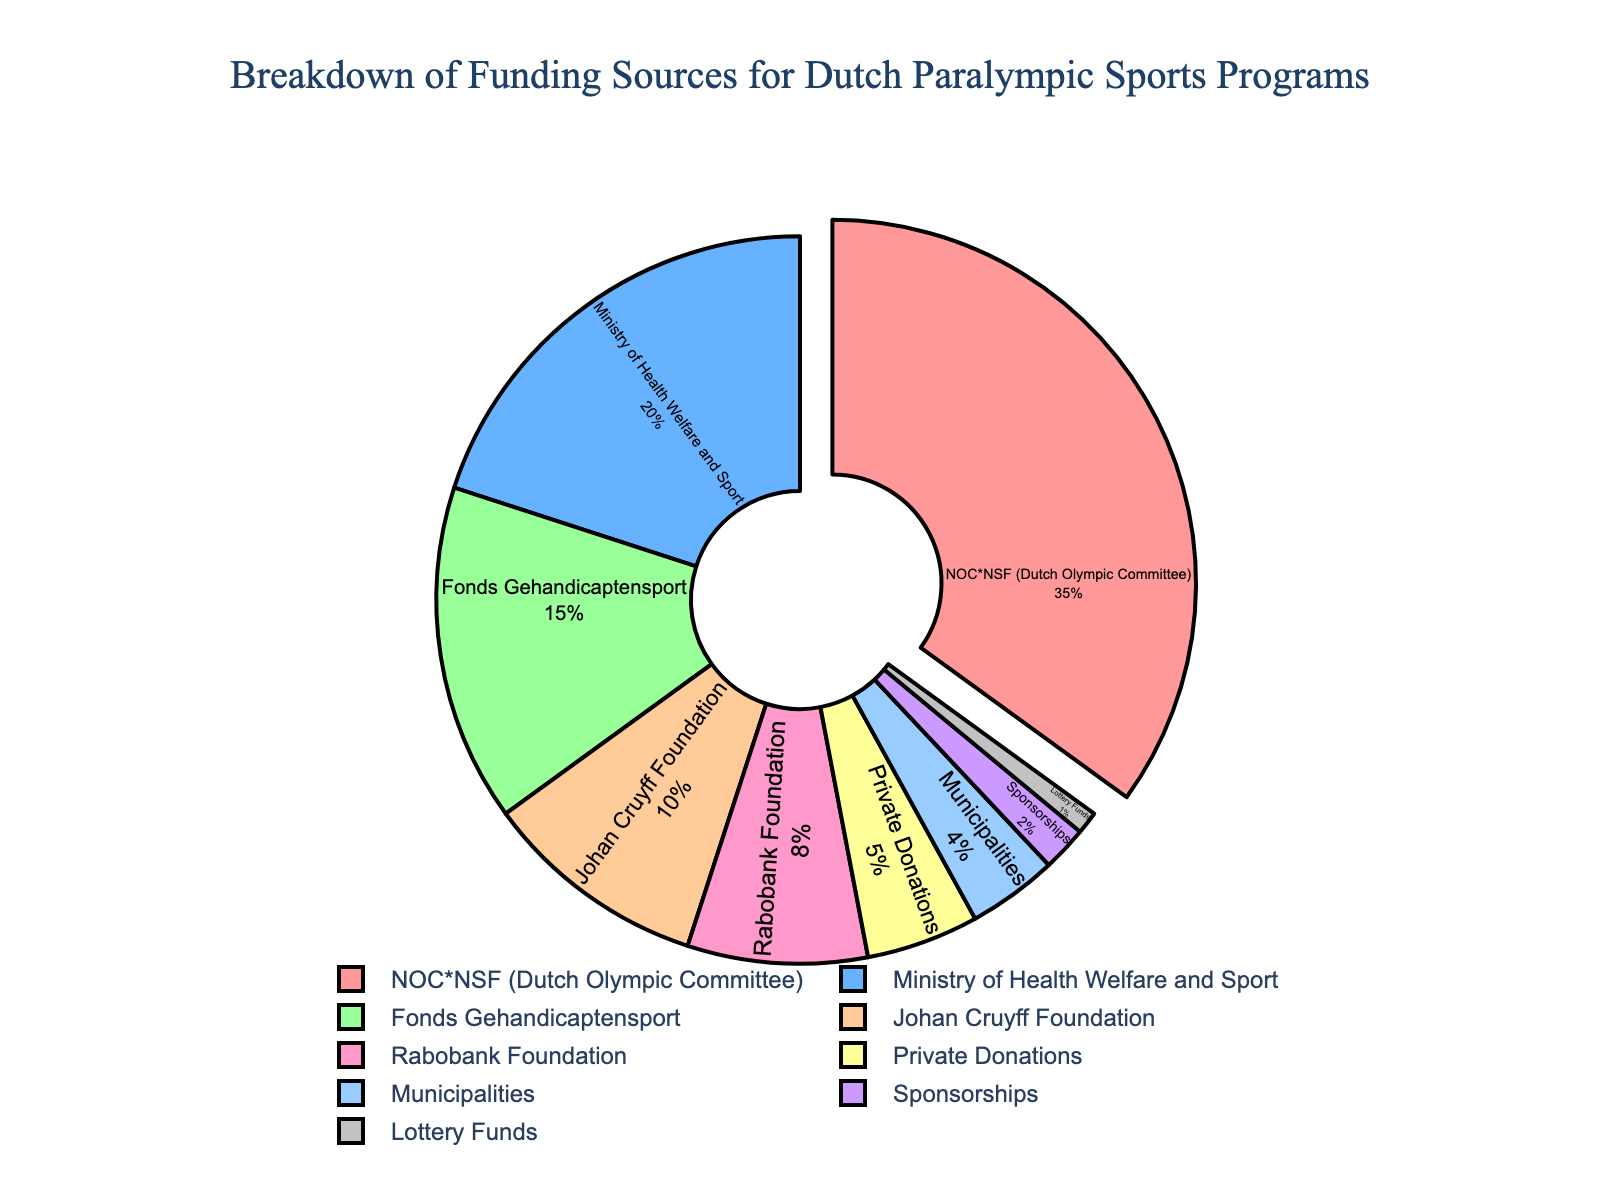Which funding source provides the highest percentage of funding? The largest segment in the pie chart is visibly larger than the others and is labeled most prominently. We can see that the funding source labeled "NOC*NSF (Dutch Olympic Committee)" provides 35%, which is the highest.
Answer: NOC*NSF (Dutch Olympic Committee) Which two funding sources together provide more than half of the total funding? We need to find two segments that, when added together, sum to over 50%. The largest two portions are from the NOC*NSF (35%) and Ministry of Health Welfare and Sport (20%). Summing these gives 35% + 20% = 55%, which is more than half.
Answer: NOC*NSF and Ministry of Health Welfare and Sport What is the difference in funding percentages between the highest and the lowest funding sources? Identify the highest (NOC*NSF at 35%) and lowest (Lottery Funds at 1%) percentages in the chart, then subtract the lowest from the highest: 35% - 1% = 34%.
Answer: 34% Which color represents the Fonds Gehandicaptensport funding source in the pie chart? By examining the colors and matching them with the labels in the chart, we'll find that Fonds Gehandicaptensport is colored in green as it matches with the 15% segment.
Answer: Green How many funding sources provide less than 10% of the total funding each? By counting the segments whose labels show percentages less than 10%, we see that these are Rabobank Foundation (8%), Private Donations (5%), Municipalities (4%), Sponsorships (2%), and Lottery Funds (1%). Thus there are five such sources.
Answer: 5 What is the combined percentage of funding from private donations, municipalities, and lottery funds? Add the percentages from these three sources: Private Donations (5%) + Municipalities (4%) + Lottery Funds (1%) = 5% + 4% + 1% = 10%.
Answer: 10% If the NOC*NSF section is "pulled" out from the pie chart, how does this impact the chart's visual representation? This section likely stands out or separates from the rest, visually highlighting it as the most significant contributor. The pulling action makes it noticeable that the NOC*NSF accounts for the largest share.
Answer: Highlights NOC*NSF as the largest share Which funding source is the closest to doubling the percentage of Johan Cruyff Foundation? The Johan Cruyff Foundation is at 10%. Doubling this is 20%, and we look for the closest available percentage. The Ministry of Health Welfare and Sport is exactly 20%, making it the closest.
Answer: Ministry of Health Welfare and Sport Is the sum of the percentages of Rabobank Foundation and Sponsorships greater than the percentage of Fonds Gehandicaptensport? Rabobank Foundation is 8%, Sponsorships is 2%, so their sum is 8% + 2% = 10%. Fonds Gehandicaptensport is 15%. Therefore, 10% is not greater than 15%.
Answer: No Which funding sources together provide exactly 30% of the total funding? To find a combination totaling 30%, consider potential sums of lower percentages. NOC*NSF (35%) is excluded since it's greater alone. Ministry of Health Welfare and Sport (20%) plus Johan Cruyff Foundation (10%) gives 20% + 10% = 30%.
Answer: Ministry of Health Welfare and Sport and Johan Cruyff Foundation 